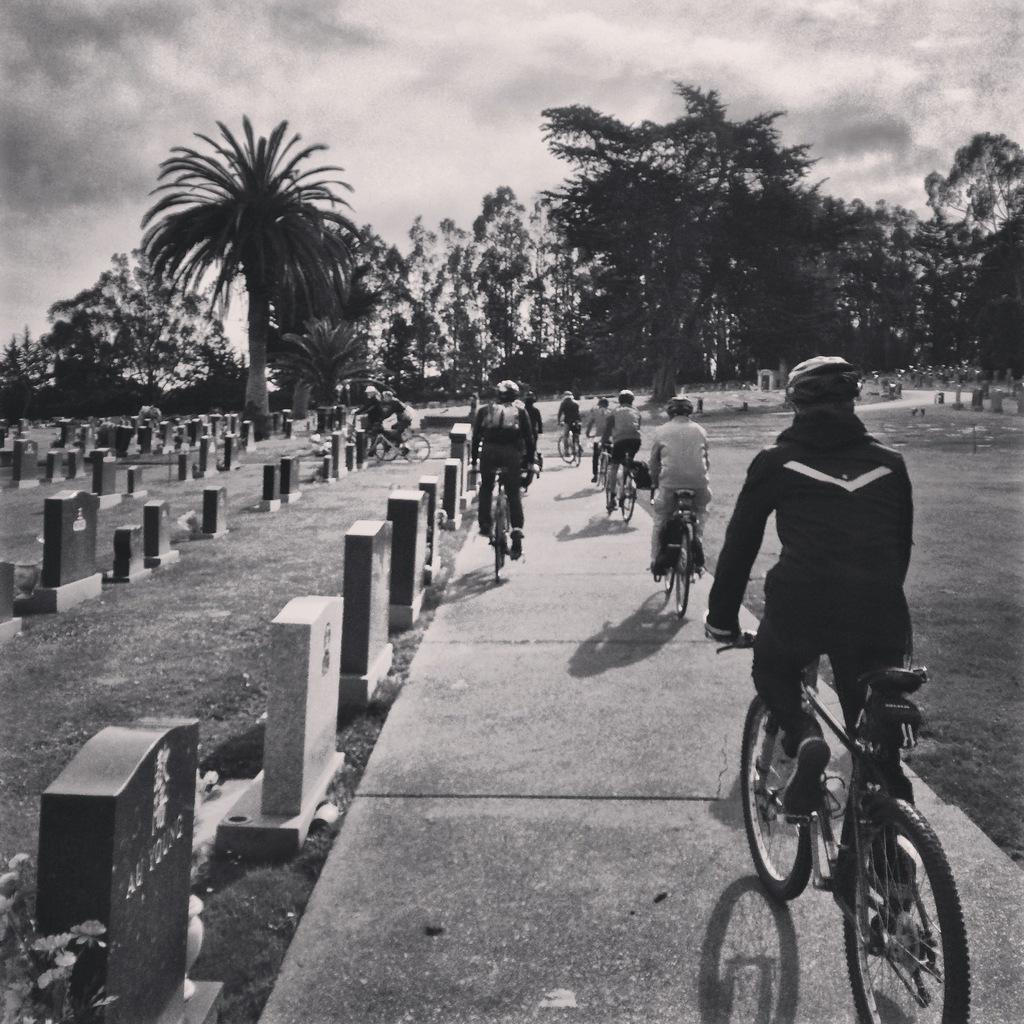What are the people in the image doing? The people in the image are riding bicycles. Where are the people riding their bicycles? The people are riding their bicycles on a path. What type of natural elements can be seen in the image? There are trees and plants in the image. Can you tell me how many people are fighting with a gun in the image? There is no fighting or gun present in the image; it features people riding bicycles on a path surrounded by trees and plants. 